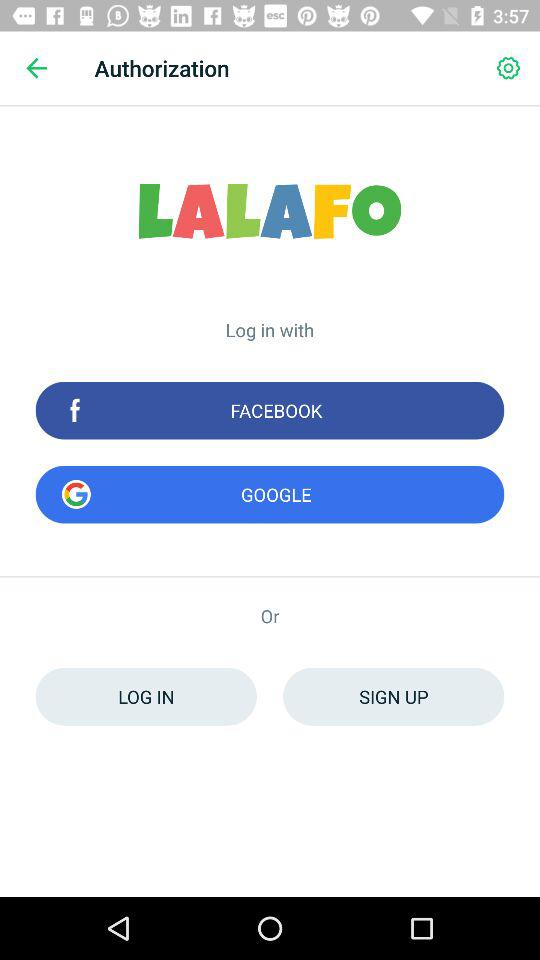What accounts can I use to log in? You can log in with "FACEBOOK" and "GOOGLE". 